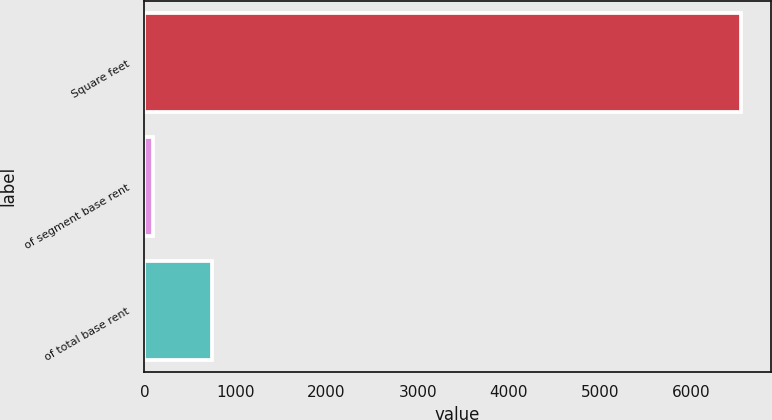<chart> <loc_0><loc_0><loc_500><loc_500><bar_chart><fcel>Square feet<fcel>of segment base rent<fcel>of total base rent<nl><fcel>6545<fcel>100<fcel>744.5<nl></chart> 